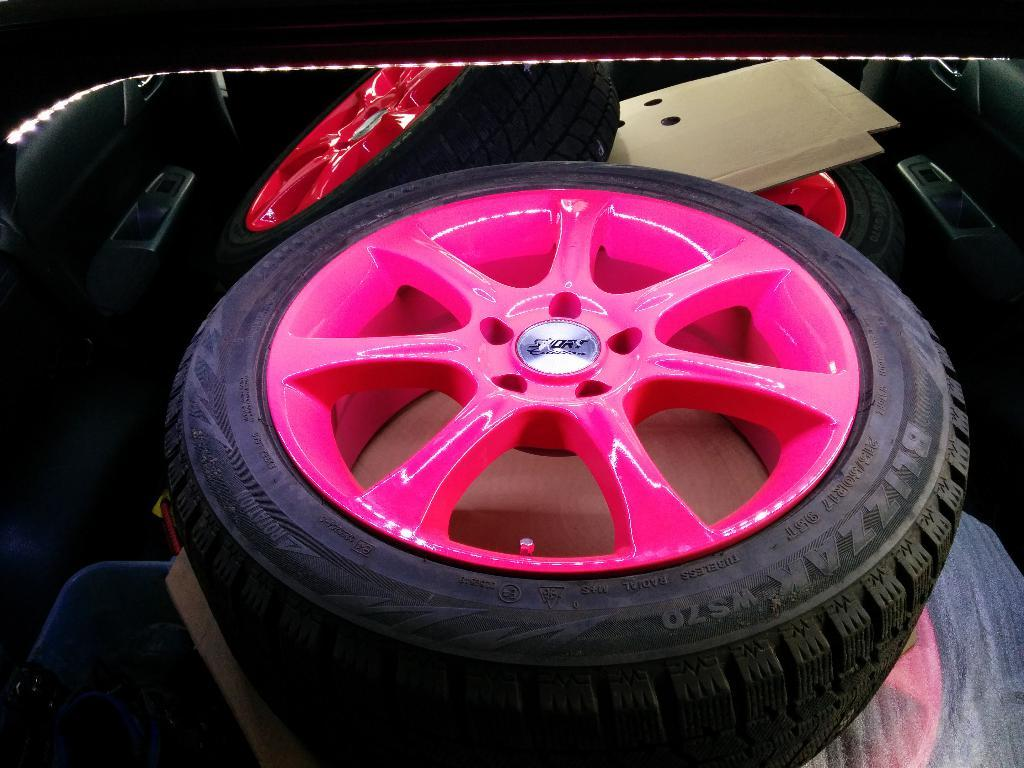What is the main subject of the image? The main subject of the image is a group of wheels. Can you describe the context in which the wheels are placed? There is a cardboard placed inside a car in the image. What type of expert advice can be seen on the cardboard in the image? There is no expert advice present on the cardboard in the image. What material is the brass used for in the image? There is no brass present in the image. 